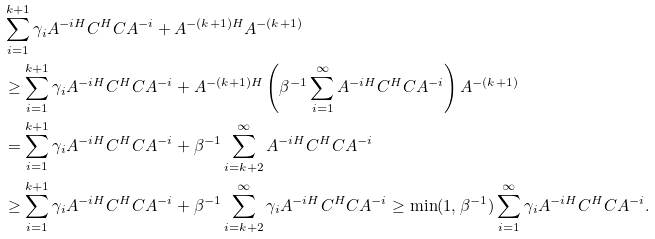Convert formula to latex. <formula><loc_0><loc_0><loc_500><loc_500>& \sum _ { i = 1 } ^ { k + 1 } \gamma _ { i } A ^ { - i H } C ^ { H } C A ^ { - i } + A ^ { - ( k + 1 ) H } A ^ { - ( k + 1 ) } \\ & \geq \sum _ { i = 1 } ^ { k + 1 } \gamma _ { i } A ^ { - i H } C ^ { H } C A ^ { - i } + A ^ { - ( k + 1 ) H } \left ( \beta ^ { - 1 } \sum _ { i = 1 } ^ { \infty } A ^ { - i H } C ^ { H } C A ^ { - i } \right ) A ^ { - ( k + 1 ) } \\ & = \sum _ { i = 1 } ^ { k + 1 } \gamma _ { i } A ^ { - i H } C ^ { H } C A ^ { - i } + \beta ^ { - 1 } \sum _ { i = k + 2 } ^ { \infty } A ^ { - i H } C ^ { H } C A ^ { - i } \\ & \geq \sum _ { i = 1 } ^ { k + 1 } \gamma _ { i } A ^ { - i H } C ^ { H } C A ^ { - i } + \beta ^ { - 1 } \sum _ { i = k + 2 } ^ { \infty } \gamma _ { i } A ^ { - i H } C ^ { H } C A ^ { - i } \geq \min ( 1 , \beta ^ { - 1 } ) \sum _ { i = 1 } ^ { \infty } \gamma _ { i } A ^ { - i H } C ^ { H } C A ^ { - i } .</formula> 